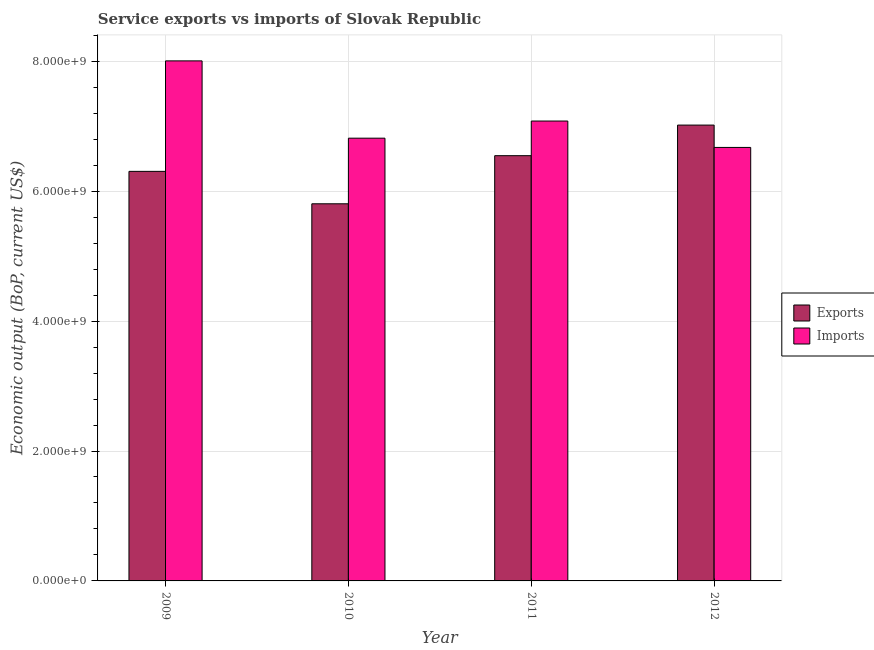Are the number of bars per tick equal to the number of legend labels?
Your response must be concise. Yes. Are the number of bars on each tick of the X-axis equal?
Your response must be concise. Yes. How many bars are there on the 1st tick from the left?
Ensure brevity in your answer.  2. What is the label of the 3rd group of bars from the left?
Provide a succinct answer. 2011. In how many cases, is the number of bars for a given year not equal to the number of legend labels?
Your answer should be compact. 0. What is the amount of service exports in 2009?
Your answer should be very brief. 6.31e+09. Across all years, what is the maximum amount of service imports?
Offer a very short reply. 8.01e+09. Across all years, what is the minimum amount of service imports?
Provide a short and direct response. 6.67e+09. In which year was the amount of service imports maximum?
Ensure brevity in your answer.  2009. In which year was the amount of service exports minimum?
Your response must be concise. 2010. What is the total amount of service imports in the graph?
Your answer should be compact. 2.86e+1. What is the difference between the amount of service exports in 2009 and that in 2011?
Offer a very short reply. -2.42e+08. What is the difference between the amount of service exports in 2012 and the amount of service imports in 2009?
Offer a terse response. 7.13e+08. What is the average amount of service imports per year?
Make the answer very short. 7.14e+09. In the year 2010, what is the difference between the amount of service imports and amount of service exports?
Give a very brief answer. 0. What is the ratio of the amount of service exports in 2010 to that in 2011?
Offer a terse response. 0.89. Is the difference between the amount of service imports in 2009 and 2012 greater than the difference between the amount of service exports in 2009 and 2012?
Offer a very short reply. No. What is the difference between the highest and the second highest amount of service exports?
Provide a short and direct response. 4.71e+08. What is the difference between the highest and the lowest amount of service imports?
Provide a short and direct response. 1.33e+09. Is the sum of the amount of service exports in 2010 and 2012 greater than the maximum amount of service imports across all years?
Your response must be concise. Yes. What does the 2nd bar from the left in 2012 represents?
Provide a short and direct response. Imports. What does the 1st bar from the right in 2010 represents?
Your answer should be compact. Imports. How many bars are there?
Give a very brief answer. 8. Are the values on the major ticks of Y-axis written in scientific E-notation?
Offer a very short reply. Yes. Does the graph contain any zero values?
Your answer should be very brief. No. Where does the legend appear in the graph?
Your response must be concise. Center right. How are the legend labels stacked?
Provide a short and direct response. Vertical. What is the title of the graph?
Offer a terse response. Service exports vs imports of Slovak Republic. Does "Infant" appear as one of the legend labels in the graph?
Offer a very short reply. No. What is the label or title of the Y-axis?
Offer a terse response. Economic output (BoP, current US$). What is the Economic output (BoP, current US$) of Exports in 2009?
Your answer should be very brief. 6.31e+09. What is the Economic output (BoP, current US$) of Imports in 2009?
Provide a short and direct response. 8.01e+09. What is the Economic output (BoP, current US$) in Exports in 2010?
Your answer should be very brief. 5.81e+09. What is the Economic output (BoP, current US$) in Imports in 2010?
Provide a short and direct response. 6.82e+09. What is the Economic output (BoP, current US$) of Exports in 2011?
Offer a terse response. 6.55e+09. What is the Economic output (BoP, current US$) in Imports in 2011?
Provide a succinct answer. 7.08e+09. What is the Economic output (BoP, current US$) of Exports in 2012?
Keep it short and to the point. 7.02e+09. What is the Economic output (BoP, current US$) in Imports in 2012?
Offer a very short reply. 6.67e+09. Across all years, what is the maximum Economic output (BoP, current US$) of Exports?
Offer a very short reply. 7.02e+09. Across all years, what is the maximum Economic output (BoP, current US$) in Imports?
Your response must be concise. 8.01e+09. Across all years, what is the minimum Economic output (BoP, current US$) in Exports?
Provide a short and direct response. 5.81e+09. Across all years, what is the minimum Economic output (BoP, current US$) in Imports?
Offer a terse response. 6.67e+09. What is the total Economic output (BoP, current US$) in Exports in the graph?
Ensure brevity in your answer.  2.57e+1. What is the total Economic output (BoP, current US$) in Imports in the graph?
Keep it short and to the point. 2.86e+1. What is the difference between the Economic output (BoP, current US$) in Exports in 2009 and that in 2010?
Provide a succinct answer. 4.99e+08. What is the difference between the Economic output (BoP, current US$) in Imports in 2009 and that in 2010?
Keep it short and to the point. 1.19e+09. What is the difference between the Economic output (BoP, current US$) in Exports in 2009 and that in 2011?
Offer a very short reply. -2.42e+08. What is the difference between the Economic output (BoP, current US$) in Imports in 2009 and that in 2011?
Offer a very short reply. 9.26e+08. What is the difference between the Economic output (BoP, current US$) in Exports in 2009 and that in 2012?
Give a very brief answer. -7.13e+08. What is the difference between the Economic output (BoP, current US$) in Imports in 2009 and that in 2012?
Make the answer very short. 1.33e+09. What is the difference between the Economic output (BoP, current US$) of Exports in 2010 and that in 2011?
Your answer should be compact. -7.41e+08. What is the difference between the Economic output (BoP, current US$) of Imports in 2010 and that in 2011?
Provide a succinct answer. -2.64e+08. What is the difference between the Economic output (BoP, current US$) of Exports in 2010 and that in 2012?
Make the answer very short. -1.21e+09. What is the difference between the Economic output (BoP, current US$) of Imports in 2010 and that in 2012?
Offer a terse response. 1.42e+08. What is the difference between the Economic output (BoP, current US$) of Exports in 2011 and that in 2012?
Provide a succinct answer. -4.71e+08. What is the difference between the Economic output (BoP, current US$) in Imports in 2011 and that in 2012?
Offer a very short reply. 4.06e+08. What is the difference between the Economic output (BoP, current US$) in Exports in 2009 and the Economic output (BoP, current US$) in Imports in 2010?
Keep it short and to the point. -5.11e+08. What is the difference between the Economic output (BoP, current US$) in Exports in 2009 and the Economic output (BoP, current US$) in Imports in 2011?
Ensure brevity in your answer.  -7.75e+08. What is the difference between the Economic output (BoP, current US$) of Exports in 2009 and the Economic output (BoP, current US$) of Imports in 2012?
Provide a succinct answer. -3.69e+08. What is the difference between the Economic output (BoP, current US$) in Exports in 2010 and the Economic output (BoP, current US$) in Imports in 2011?
Ensure brevity in your answer.  -1.27e+09. What is the difference between the Economic output (BoP, current US$) in Exports in 2010 and the Economic output (BoP, current US$) in Imports in 2012?
Offer a terse response. -8.68e+08. What is the difference between the Economic output (BoP, current US$) of Exports in 2011 and the Economic output (BoP, current US$) of Imports in 2012?
Ensure brevity in your answer.  -1.27e+08. What is the average Economic output (BoP, current US$) in Exports per year?
Keep it short and to the point. 6.42e+09. What is the average Economic output (BoP, current US$) in Imports per year?
Ensure brevity in your answer.  7.14e+09. In the year 2009, what is the difference between the Economic output (BoP, current US$) of Exports and Economic output (BoP, current US$) of Imports?
Offer a terse response. -1.70e+09. In the year 2010, what is the difference between the Economic output (BoP, current US$) of Exports and Economic output (BoP, current US$) of Imports?
Your answer should be compact. -1.01e+09. In the year 2011, what is the difference between the Economic output (BoP, current US$) of Exports and Economic output (BoP, current US$) of Imports?
Give a very brief answer. -5.33e+08. In the year 2012, what is the difference between the Economic output (BoP, current US$) of Exports and Economic output (BoP, current US$) of Imports?
Give a very brief answer. 3.44e+08. What is the ratio of the Economic output (BoP, current US$) in Exports in 2009 to that in 2010?
Ensure brevity in your answer.  1.09. What is the ratio of the Economic output (BoP, current US$) of Imports in 2009 to that in 2010?
Provide a succinct answer. 1.17. What is the ratio of the Economic output (BoP, current US$) in Exports in 2009 to that in 2011?
Offer a terse response. 0.96. What is the ratio of the Economic output (BoP, current US$) of Imports in 2009 to that in 2011?
Keep it short and to the point. 1.13. What is the ratio of the Economic output (BoP, current US$) in Exports in 2009 to that in 2012?
Your answer should be compact. 0.9. What is the ratio of the Economic output (BoP, current US$) in Imports in 2009 to that in 2012?
Your answer should be very brief. 1.2. What is the ratio of the Economic output (BoP, current US$) of Exports in 2010 to that in 2011?
Make the answer very short. 0.89. What is the ratio of the Economic output (BoP, current US$) of Imports in 2010 to that in 2011?
Offer a terse response. 0.96. What is the ratio of the Economic output (BoP, current US$) in Exports in 2010 to that in 2012?
Your answer should be very brief. 0.83. What is the ratio of the Economic output (BoP, current US$) of Imports in 2010 to that in 2012?
Make the answer very short. 1.02. What is the ratio of the Economic output (BoP, current US$) of Exports in 2011 to that in 2012?
Ensure brevity in your answer.  0.93. What is the ratio of the Economic output (BoP, current US$) in Imports in 2011 to that in 2012?
Your answer should be compact. 1.06. What is the difference between the highest and the second highest Economic output (BoP, current US$) in Exports?
Keep it short and to the point. 4.71e+08. What is the difference between the highest and the second highest Economic output (BoP, current US$) of Imports?
Your response must be concise. 9.26e+08. What is the difference between the highest and the lowest Economic output (BoP, current US$) of Exports?
Provide a succinct answer. 1.21e+09. What is the difference between the highest and the lowest Economic output (BoP, current US$) of Imports?
Your answer should be very brief. 1.33e+09. 